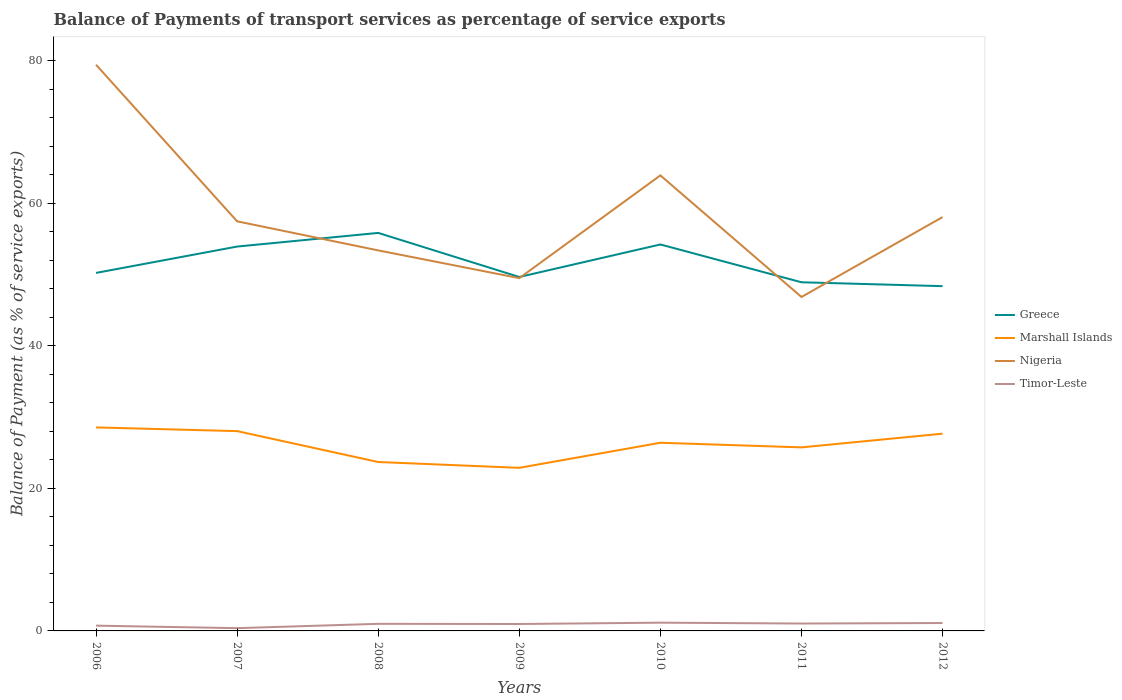Across all years, what is the maximum balance of payments of transport services in Marshall Islands?
Keep it short and to the point. 22.89. In which year was the balance of payments of transport services in Marshall Islands maximum?
Ensure brevity in your answer.  2009. What is the total balance of payments of transport services in Timor-Leste in the graph?
Keep it short and to the point. 0.35. What is the difference between the highest and the second highest balance of payments of transport services in Marshall Islands?
Your answer should be very brief. 5.67. How many lines are there?
Your response must be concise. 4. Does the graph contain grids?
Make the answer very short. No. How many legend labels are there?
Provide a short and direct response. 4. What is the title of the graph?
Give a very brief answer. Balance of Payments of transport services as percentage of service exports. Does "Slovak Republic" appear as one of the legend labels in the graph?
Your answer should be compact. No. What is the label or title of the X-axis?
Give a very brief answer. Years. What is the label or title of the Y-axis?
Your answer should be very brief. Balance of Payment (as % of service exports). What is the Balance of Payment (as % of service exports) in Greece in 2006?
Ensure brevity in your answer.  50.25. What is the Balance of Payment (as % of service exports) in Marshall Islands in 2006?
Your answer should be compact. 28.56. What is the Balance of Payment (as % of service exports) in Nigeria in 2006?
Your answer should be very brief. 79.47. What is the Balance of Payment (as % of service exports) in Timor-Leste in 2006?
Ensure brevity in your answer.  0.74. What is the Balance of Payment (as % of service exports) in Greece in 2007?
Keep it short and to the point. 53.95. What is the Balance of Payment (as % of service exports) in Marshall Islands in 2007?
Your answer should be compact. 28.05. What is the Balance of Payment (as % of service exports) in Nigeria in 2007?
Your answer should be compact. 57.49. What is the Balance of Payment (as % of service exports) in Timor-Leste in 2007?
Offer a very short reply. 0.39. What is the Balance of Payment (as % of service exports) in Greece in 2008?
Offer a very short reply. 55.87. What is the Balance of Payment (as % of service exports) of Marshall Islands in 2008?
Make the answer very short. 23.71. What is the Balance of Payment (as % of service exports) of Nigeria in 2008?
Keep it short and to the point. 53.41. What is the Balance of Payment (as % of service exports) in Timor-Leste in 2008?
Offer a very short reply. 1. What is the Balance of Payment (as % of service exports) of Greece in 2009?
Provide a short and direct response. 49.68. What is the Balance of Payment (as % of service exports) in Marshall Islands in 2009?
Ensure brevity in your answer.  22.89. What is the Balance of Payment (as % of service exports) of Nigeria in 2009?
Provide a succinct answer. 49.52. What is the Balance of Payment (as % of service exports) of Timor-Leste in 2009?
Your response must be concise. 0.97. What is the Balance of Payment (as % of service exports) of Greece in 2010?
Your answer should be very brief. 54.25. What is the Balance of Payment (as % of service exports) in Marshall Islands in 2010?
Keep it short and to the point. 26.41. What is the Balance of Payment (as % of service exports) of Nigeria in 2010?
Your response must be concise. 63.94. What is the Balance of Payment (as % of service exports) of Timor-Leste in 2010?
Your response must be concise. 1.16. What is the Balance of Payment (as % of service exports) in Greece in 2011?
Your response must be concise. 48.94. What is the Balance of Payment (as % of service exports) of Marshall Islands in 2011?
Provide a short and direct response. 25.76. What is the Balance of Payment (as % of service exports) in Nigeria in 2011?
Make the answer very short. 46.87. What is the Balance of Payment (as % of service exports) in Timor-Leste in 2011?
Make the answer very short. 1.04. What is the Balance of Payment (as % of service exports) of Greece in 2012?
Your answer should be compact. 48.39. What is the Balance of Payment (as % of service exports) of Marshall Islands in 2012?
Provide a short and direct response. 27.69. What is the Balance of Payment (as % of service exports) of Nigeria in 2012?
Provide a succinct answer. 58.09. What is the Balance of Payment (as % of service exports) in Timor-Leste in 2012?
Offer a very short reply. 1.11. Across all years, what is the maximum Balance of Payment (as % of service exports) in Greece?
Keep it short and to the point. 55.87. Across all years, what is the maximum Balance of Payment (as % of service exports) in Marshall Islands?
Give a very brief answer. 28.56. Across all years, what is the maximum Balance of Payment (as % of service exports) in Nigeria?
Make the answer very short. 79.47. Across all years, what is the maximum Balance of Payment (as % of service exports) of Timor-Leste?
Keep it short and to the point. 1.16. Across all years, what is the minimum Balance of Payment (as % of service exports) of Greece?
Your answer should be very brief. 48.39. Across all years, what is the minimum Balance of Payment (as % of service exports) in Marshall Islands?
Keep it short and to the point. 22.89. Across all years, what is the minimum Balance of Payment (as % of service exports) in Nigeria?
Your answer should be compact. 46.87. Across all years, what is the minimum Balance of Payment (as % of service exports) of Timor-Leste?
Keep it short and to the point. 0.39. What is the total Balance of Payment (as % of service exports) in Greece in the graph?
Your response must be concise. 361.34. What is the total Balance of Payment (as % of service exports) of Marshall Islands in the graph?
Offer a terse response. 183.08. What is the total Balance of Payment (as % of service exports) of Nigeria in the graph?
Provide a succinct answer. 408.81. What is the total Balance of Payment (as % of service exports) of Timor-Leste in the graph?
Your answer should be compact. 6.4. What is the difference between the Balance of Payment (as % of service exports) in Greece in 2006 and that in 2007?
Offer a terse response. -3.7. What is the difference between the Balance of Payment (as % of service exports) in Marshall Islands in 2006 and that in 2007?
Offer a very short reply. 0.52. What is the difference between the Balance of Payment (as % of service exports) of Nigeria in 2006 and that in 2007?
Provide a short and direct response. 21.98. What is the difference between the Balance of Payment (as % of service exports) in Timor-Leste in 2006 and that in 2007?
Your answer should be very brief. 0.35. What is the difference between the Balance of Payment (as % of service exports) in Greece in 2006 and that in 2008?
Provide a succinct answer. -5.61. What is the difference between the Balance of Payment (as % of service exports) in Marshall Islands in 2006 and that in 2008?
Keep it short and to the point. 4.85. What is the difference between the Balance of Payment (as % of service exports) in Nigeria in 2006 and that in 2008?
Your answer should be compact. 26.06. What is the difference between the Balance of Payment (as % of service exports) of Timor-Leste in 2006 and that in 2008?
Offer a very short reply. -0.26. What is the difference between the Balance of Payment (as % of service exports) of Greece in 2006 and that in 2009?
Offer a terse response. 0.57. What is the difference between the Balance of Payment (as % of service exports) in Marshall Islands in 2006 and that in 2009?
Provide a succinct answer. 5.67. What is the difference between the Balance of Payment (as % of service exports) of Nigeria in 2006 and that in 2009?
Your response must be concise. 29.95. What is the difference between the Balance of Payment (as % of service exports) in Timor-Leste in 2006 and that in 2009?
Make the answer very short. -0.23. What is the difference between the Balance of Payment (as % of service exports) in Greece in 2006 and that in 2010?
Your answer should be compact. -3.99. What is the difference between the Balance of Payment (as % of service exports) of Marshall Islands in 2006 and that in 2010?
Offer a very short reply. 2.15. What is the difference between the Balance of Payment (as % of service exports) of Nigeria in 2006 and that in 2010?
Give a very brief answer. 15.53. What is the difference between the Balance of Payment (as % of service exports) of Timor-Leste in 2006 and that in 2010?
Offer a very short reply. -0.42. What is the difference between the Balance of Payment (as % of service exports) in Greece in 2006 and that in 2011?
Offer a very short reply. 1.31. What is the difference between the Balance of Payment (as % of service exports) of Marshall Islands in 2006 and that in 2011?
Make the answer very short. 2.8. What is the difference between the Balance of Payment (as % of service exports) of Nigeria in 2006 and that in 2011?
Offer a terse response. 32.6. What is the difference between the Balance of Payment (as % of service exports) of Timor-Leste in 2006 and that in 2011?
Give a very brief answer. -0.3. What is the difference between the Balance of Payment (as % of service exports) in Greece in 2006 and that in 2012?
Ensure brevity in your answer.  1.86. What is the difference between the Balance of Payment (as % of service exports) in Marshall Islands in 2006 and that in 2012?
Provide a succinct answer. 0.88. What is the difference between the Balance of Payment (as % of service exports) of Nigeria in 2006 and that in 2012?
Your answer should be compact. 21.38. What is the difference between the Balance of Payment (as % of service exports) of Timor-Leste in 2006 and that in 2012?
Offer a terse response. -0.37. What is the difference between the Balance of Payment (as % of service exports) in Greece in 2007 and that in 2008?
Offer a terse response. -1.92. What is the difference between the Balance of Payment (as % of service exports) of Marshall Islands in 2007 and that in 2008?
Provide a short and direct response. 4.34. What is the difference between the Balance of Payment (as % of service exports) in Nigeria in 2007 and that in 2008?
Give a very brief answer. 4.08. What is the difference between the Balance of Payment (as % of service exports) of Timor-Leste in 2007 and that in 2008?
Make the answer very short. -0.61. What is the difference between the Balance of Payment (as % of service exports) in Greece in 2007 and that in 2009?
Give a very brief answer. 4.27. What is the difference between the Balance of Payment (as % of service exports) in Marshall Islands in 2007 and that in 2009?
Your answer should be very brief. 5.15. What is the difference between the Balance of Payment (as % of service exports) in Nigeria in 2007 and that in 2009?
Your answer should be very brief. 7.98. What is the difference between the Balance of Payment (as % of service exports) of Timor-Leste in 2007 and that in 2009?
Provide a succinct answer. -0.58. What is the difference between the Balance of Payment (as % of service exports) in Greece in 2007 and that in 2010?
Your answer should be very brief. -0.29. What is the difference between the Balance of Payment (as % of service exports) in Marshall Islands in 2007 and that in 2010?
Provide a short and direct response. 1.63. What is the difference between the Balance of Payment (as % of service exports) of Nigeria in 2007 and that in 2010?
Your answer should be compact. -6.45. What is the difference between the Balance of Payment (as % of service exports) in Timor-Leste in 2007 and that in 2010?
Your answer should be very brief. -0.77. What is the difference between the Balance of Payment (as % of service exports) in Greece in 2007 and that in 2011?
Provide a short and direct response. 5.01. What is the difference between the Balance of Payment (as % of service exports) in Marshall Islands in 2007 and that in 2011?
Provide a succinct answer. 2.28. What is the difference between the Balance of Payment (as % of service exports) in Nigeria in 2007 and that in 2011?
Your answer should be compact. 10.62. What is the difference between the Balance of Payment (as % of service exports) of Timor-Leste in 2007 and that in 2011?
Ensure brevity in your answer.  -0.65. What is the difference between the Balance of Payment (as % of service exports) in Greece in 2007 and that in 2012?
Your response must be concise. 5.56. What is the difference between the Balance of Payment (as % of service exports) in Marshall Islands in 2007 and that in 2012?
Keep it short and to the point. 0.36. What is the difference between the Balance of Payment (as % of service exports) in Nigeria in 2007 and that in 2012?
Your response must be concise. -0.6. What is the difference between the Balance of Payment (as % of service exports) of Timor-Leste in 2007 and that in 2012?
Your answer should be very brief. -0.72. What is the difference between the Balance of Payment (as % of service exports) of Greece in 2008 and that in 2009?
Offer a terse response. 6.19. What is the difference between the Balance of Payment (as % of service exports) in Marshall Islands in 2008 and that in 2009?
Your answer should be very brief. 0.82. What is the difference between the Balance of Payment (as % of service exports) in Nigeria in 2008 and that in 2009?
Your answer should be very brief. 3.89. What is the difference between the Balance of Payment (as % of service exports) in Timor-Leste in 2008 and that in 2009?
Keep it short and to the point. 0.02. What is the difference between the Balance of Payment (as % of service exports) of Greece in 2008 and that in 2010?
Offer a very short reply. 1.62. What is the difference between the Balance of Payment (as % of service exports) of Marshall Islands in 2008 and that in 2010?
Your response must be concise. -2.7. What is the difference between the Balance of Payment (as % of service exports) of Nigeria in 2008 and that in 2010?
Keep it short and to the point. -10.53. What is the difference between the Balance of Payment (as % of service exports) in Timor-Leste in 2008 and that in 2010?
Ensure brevity in your answer.  -0.16. What is the difference between the Balance of Payment (as % of service exports) of Greece in 2008 and that in 2011?
Make the answer very short. 6.93. What is the difference between the Balance of Payment (as % of service exports) of Marshall Islands in 2008 and that in 2011?
Make the answer very short. -2.05. What is the difference between the Balance of Payment (as % of service exports) of Nigeria in 2008 and that in 2011?
Provide a succinct answer. 6.54. What is the difference between the Balance of Payment (as % of service exports) of Timor-Leste in 2008 and that in 2011?
Make the answer very short. -0.04. What is the difference between the Balance of Payment (as % of service exports) in Greece in 2008 and that in 2012?
Keep it short and to the point. 7.47. What is the difference between the Balance of Payment (as % of service exports) of Marshall Islands in 2008 and that in 2012?
Make the answer very short. -3.98. What is the difference between the Balance of Payment (as % of service exports) in Nigeria in 2008 and that in 2012?
Your response must be concise. -4.68. What is the difference between the Balance of Payment (as % of service exports) of Timor-Leste in 2008 and that in 2012?
Provide a short and direct response. -0.11. What is the difference between the Balance of Payment (as % of service exports) of Greece in 2009 and that in 2010?
Your answer should be compact. -4.57. What is the difference between the Balance of Payment (as % of service exports) in Marshall Islands in 2009 and that in 2010?
Provide a succinct answer. -3.52. What is the difference between the Balance of Payment (as % of service exports) in Nigeria in 2009 and that in 2010?
Your answer should be compact. -14.43. What is the difference between the Balance of Payment (as % of service exports) in Timor-Leste in 2009 and that in 2010?
Your answer should be very brief. -0.19. What is the difference between the Balance of Payment (as % of service exports) in Greece in 2009 and that in 2011?
Provide a short and direct response. 0.74. What is the difference between the Balance of Payment (as % of service exports) in Marshall Islands in 2009 and that in 2011?
Your response must be concise. -2.87. What is the difference between the Balance of Payment (as % of service exports) in Nigeria in 2009 and that in 2011?
Ensure brevity in your answer.  2.64. What is the difference between the Balance of Payment (as % of service exports) of Timor-Leste in 2009 and that in 2011?
Provide a short and direct response. -0.07. What is the difference between the Balance of Payment (as % of service exports) of Marshall Islands in 2009 and that in 2012?
Provide a short and direct response. -4.8. What is the difference between the Balance of Payment (as % of service exports) of Nigeria in 2009 and that in 2012?
Provide a succinct answer. -8.57. What is the difference between the Balance of Payment (as % of service exports) of Timor-Leste in 2009 and that in 2012?
Make the answer very short. -0.14. What is the difference between the Balance of Payment (as % of service exports) in Greece in 2010 and that in 2011?
Keep it short and to the point. 5.31. What is the difference between the Balance of Payment (as % of service exports) in Marshall Islands in 2010 and that in 2011?
Ensure brevity in your answer.  0.65. What is the difference between the Balance of Payment (as % of service exports) of Nigeria in 2010 and that in 2011?
Your answer should be compact. 17.07. What is the difference between the Balance of Payment (as % of service exports) of Timor-Leste in 2010 and that in 2011?
Provide a short and direct response. 0.12. What is the difference between the Balance of Payment (as % of service exports) in Greece in 2010 and that in 2012?
Make the answer very short. 5.85. What is the difference between the Balance of Payment (as % of service exports) in Marshall Islands in 2010 and that in 2012?
Your answer should be very brief. -1.27. What is the difference between the Balance of Payment (as % of service exports) in Nigeria in 2010 and that in 2012?
Your response must be concise. 5.85. What is the difference between the Balance of Payment (as % of service exports) of Timor-Leste in 2010 and that in 2012?
Your answer should be very brief. 0.05. What is the difference between the Balance of Payment (as % of service exports) in Greece in 2011 and that in 2012?
Provide a short and direct response. 0.55. What is the difference between the Balance of Payment (as % of service exports) of Marshall Islands in 2011 and that in 2012?
Your answer should be compact. -1.92. What is the difference between the Balance of Payment (as % of service exports) of Nigeria in 2011 and that in 2012?
Keep it short and to the point. -11.22. What is the difference between the Balance of Payment (as % of service exports) in Timor-Leste in 2011 and that in 2012?
Provide a succinct answer. -0.07. What is the difference between the Balance of Payment (as % of service exports) in Greece in 2006 and the Balance of Payment (as % of service exports) in Marshall Islands in 2007?
Your answer should be very brief. 22.21. What is the difference between the Balance of Payment (as % of service exports) of Greece in 2006 and the Balance of Payment (as % of service exports) of Nigeria in 2007?
Offer a very short reply. -7.24. What is the difference between the Balance of Payment (as % of service exports) of Greece in 2006 and the Balance of Payment (as % of service exports) of Timor-Leste in 2007?
Offer a terse response. 49.86. What is the difference between the Balance of Payment (as % of service exports) in Marshall Islands in 2006 and the Balance of Payment (as % of service exports) in Nigeria in 2007?
Provide a succinct answer. -28.93. What is the difference between the Balance of Payment (as % of service exports) in Marshall Islands in 2006 and the Balance of Payment (as % of service exports) in Timor-Leste in 2007?
Offer a very short reply. 28.18. What is the difference between the Balance of Payment (as % of service exports) of Nigeria in 2006 and the Balance of Payment (as % of service exports) of Timor-Leste in 2007?
Your answer should be very brief. 79.08. What is the difference between the Balance of Payment (as % of service exports) in Greece in 2006 and the Balance of Payment (as % of service exports) in Marshall Islands in 2008?
Your answer should be compact. 26.54. What is the difference between the Balance of Payment (as % of service exports) of Greece in 2006 and the Balance of Payment (as % of service exports) of Nigeria in 2008?
Your answer should be very brief. -3.16. What is the difference between the Balance of Payment (as % of service exports) of Greece in 2006 and the Balance of Payment (as % of service exports) of Timor-Leste in 2008?
Provide a succinct answer. 49.26. What is the difference between the Balance of Payment (as % of service exports) of Marshall Islands in 2006 and the Balance of Payment (as % of service exports) of Nigeria in 2008?
Your answer should be compact. -24.85. What is the difference between the Balance of Payment (as % of service exports) of Marshall Islands in 2006 and the Balance of Payment (as % of service exports) of Timor-Leste in 2008?
Your answer should be very brief. 27.57. What is the difference between the Balance of Payment (as % of service exports) in Nigeria in 2006 and the Balance of Payment (as % of service exports) in Timor-Leste in 2008?
Give a very brief answer. 78.48. What is the difference between the Balance of Payment (as % of service exports) in Greece in 2006 and the Balance of Payment (as % of service exports) in Marshall Islands in 2009?
Offer a terse response. 27.36. What is the difference between the Balance of Payment (as % of service exports) in Greece in 2006 and the Balance of Payment (as % of service exports) in Nigeria in 2009?
Offer a terse response. 0.74. What is the difference between the Balance of Payment (as % of service exports) in Greece in 2006 and the Balance of Payment (as % of service exports) in Timor-Leste in 2009?
Your answer should be compact. 49.28. What is the difference between the Balance of Payment (as % of service exports) in Marshall Islands in 2006 and the Balance of Payment (as % of service exports) in Nigeria in 2009?
Your answer should be compact. -20.95. What is the difference between the Balance of Payment (as % of service exports) of Marshall Islands in 2006 and the Balance of Payment (as % of service exports) of Timor-Leste in 2009?
Keep it short and to the point. 27.59. What is the difference between the Balance of Payment (as % of service exports) in Nigeria in 2006 and the Balance of Payment (as % of service exports) in Timor-Leste in 2009?
Make the answer very short. 78.5. What is the difference between the Balance of Payment (as % of service exports) in Greece in 2006 and the Balance of Payment (as % of service exports) in Marshall Islands in 2010?
Your response must be concise. 23.84. What is the difference between the Balance of Payment (as % of service exports) in Greece in 2006 and the Balance of Payment (as % of service exports) in Nigeria in 2010?
Your answer should be compact. -13.69. What is the difference between the Balance of Payment (as % of service exports) of Greece in 2006 and the Balance of Payment (as % of service exports) of Timor-Leste in 2010?
Keep it short and to the point. 49.1. What is the difference between the Balance of Payment (as % of service exports) in Marshall Islands in 2006 and the Balance of Payment (as % of service exports) in Nigeria in 2010?
Your answer should be very brief. -35.38. What is the difference between the Balance of Payment (as % of service exports) of Marshall Islands in 2006 and the Balance of Payment (as % of service exports) of Timor-Leste in 2010?
Your answer should be very brief. 27.41. What is the difference between the Balance of Payment (as % of service exports) in Nigeria in 2006 and the Balance of Payment (as % of service exports) in Timor-Leste in 2010?
Provide a succinct answer. 78.32. What is the difference between the Balance of Payment (as % of service exports) in Greece in 2006 and the Balance of Payment (as % of service exports) in Marshall Islands in 2011?
Make the answer very short. 24.49. What is the difference between the Balance of Payment (as % of service exports) of Greece in 2006 and the Balance of Payment (as % of service exports) of Nigeria in 2011?
Provide a short and direct response. 3.38. What is the difference between the Balance of Payment (as % of service exports) of Greece in 2006 and the Balance of Payment (as % of service exports) of Timor-Leste in 2011?
Give a very brief answer. 49.22. What is the difference between the Balance of Payment (as % of service exports) of Marshall Islands in 2006 and the Balance of Payment (as % of service exports) of Nigeria in 2011?
Ensure brevity in your answer.  -18.31. What is the difference between the Balance of Payment (as % of service exports) of Marshall Islands in 2006 and the Balance of Payment (as % of service exports) of Timor-Leste in 2011?
Provide a succinct answer. 27.53. What is the difference between the Balance of Payment (as % of service exports) of Nigeria in 2006 and the Balance of Payment (as % of service exports) of Timor-Leste in 2011?
Offer a terse response. 78.44. What is the difference between the Balance of Payment (as % of service exports) in Greece in 2006 and the Balance of Payment (as % of service exports) in Marshall Islands in 2012?
Keep it short and to the point. 22.56. What is the difference between the Balance of Payment (as % of service exports) of Greece in 2006 and the Balance of Payment (as % of service exports) of Nigeria in 2012?
Your answer should be compact. -7.84. What is the difference between the Balance of Payment (as % of service exports) of Greece in 2006 and the Balance of Payment (as % of service exports) of Timor-Leste in 2012?
Keep it short and to the point. 49.14. What is the difference between the Balance of Payment (as % of service exports) in Marshall Islands in 2006 and the Balance of Payment (as % of service exports) in Nigeria in 2012?
Your answer should be compact. -29.53. What is the difference between the Balance of Payment (as % of service exports) in Marshall Islands in 2006 and the Balance of Payment (as % of service exports) in Timor-Leste in 2012?
Offer a terse response. 27.46. What is the difference between the Balance of Payment (as % of service exports) in Nigeria in 2006 and the Balance of Payment (as % of service exports) in Timor-Leste in 2012?
Give a very brief answer. 78.36. What is the difference between the Balance of Payment (as % of service exports) of Greece in 2007 and the Balance of Payment (as % of service exports) of Marshall Islands in 2008?
Give a very brief answer. 30.24. What is the difference between the Balance of Payment (as % of service exports) in Greece in 2007 and the Balance of Payment (as % of service exports) in Nigeria in 2008?
Offer a very short reply. 0.54. What is the difference between the Balance of Payment (as % of service exports) in Greece in 2007 and the Balance of Payment (as % of service exports) in Timor-Leste in 2008?
Keep it short and to the point. 52.96. What is the difference between the Balance of Payment (as % of service exports) of Marshall Islands in 2007 and the Balance of Payment (as % of service exports) of Nigeria in 2008?
Provide a succinct answer. -25.37. What is the difference between the Balance of Payment (as % of service exports) of Marshall Islands in 2007 and the Balance of Payment (as % of service exports) of Timor-Leste in 2008?
Ensure brevity in your answer.  27.05. What is the difference between the Balance of Payment (as % of service exports) in Nigeria in 2007 and the Balance of Payment (as % of service exports) in Timor-Leste in 2008?
Your answer should be very brief. 56.5. What is the difference between the Balance of Payment (as % of service exports) of Greece in 2007 and the Balance of Payment (as % of service exports) of Marshall Islands in 2009?
Keep it short and to the point. 31.06. What is the difference between the Balance of Payment (as % of service exports) in Greece in 2007 and the Balance of Payment (as % of service exports) in Nigeria in 2009?
Ensure brevity in your answer.  4.43. What is the difference between the Balance of Payment (as % of service exports) of Greece in 2007 and the Balance of Payment (as % of service exports) of Timor-Leste in 2009?
Your answer should be compact. 52.98. What is the difference between the Balance of Payment (as % of service exports) in Marshall Islands in 2007 and the Balance of Payment (as % of service exports) in Nigeria in 2009?
Give a very brief answer. -21.47. What is the difference between the Balance of Payment (as % of service exports) in Marshall Islands in 2007 and the Balance of Payment (as % of service exports) in Timor-Leste in 2009?
Your answer should be very brief. 27.07. What is the difference between the Balance of Payment (as % of service exports) in Nigeria in 2007 and the Balance of Payment (as % of service exports) in Timor-Leste in 2009?
Offer a terse response. 56.52. What is the difference between the Balance of Payment (as % of service exports) in Greece in 2007 and the Balance of Payment (as % of service exports) in Marshall Islands in 2010?
Offer a very short reply. 27.54. What is the difference between the Balance of Payment (as % of service exports) in Greece in 2007 and the Balance of Payment (as % of service exports) in Nigeria in 2010?
Your answer should be very brief. -9.99. What is the difference between the Balance of Payment (as % of service exports) of Greece in 2007 and the Balance of Payment (as % of service exports) of Timor-Leste in 2010?
Make the answer very short. 52.79. What is the difference between the Balance of Payment (as % of service exports) in Marshall Islands in 2007 and the Balance of Payment (as % of service exports) in Nigeria in 2010?
Your answer should be compact. -35.9. What is the difference between the Balance of Payment (as % of service exports) of Marshall Islands in 2007 and the Balance of Payment (as % of service exports) of Timor-Leste in 2010?
Keep it short and to the point. 26.89. What is the difference between the Balance of Payment (as % of service exports) of Nigeria in 2007 and the Balance of Payment (as % of service exports) of Timor-Leste in 2010?
Your answer should be compact. 56.34. What is the difference between the Balance of Payment (as % of service exports) of Greece in 2007 and the Balance of Payment (as % of service exports) of Marshall Islands in 2011?
Your response must be concise. 28.19. What is the difference between the Balance of Payment (as % of service exports) of Greece in 2007 and the Balance of Payment (as % of service exports) of Nigeria in 2011?
Provide a short and direct response. 7.08. What is the difference between the Balance of Payment (as % of service exports) of Greece in 2007 and the Balance of Payment (as % of service exports) of Timor-Leste in 2011?
Ensure brevity in your answer.  52.91. What is the difference between the Balance of Payment (as % of service exports) in Marshall Islands in 2007 and the Balance of Payment (as % of service exports) in Nigeria in 2011?
Provide a succinct answer. -18.83. What is the difference between the Balance of Payment (as % of service exports) of Marshall Islands in 2007 and the Balance of Payment (as % of service exports) of Timor-Leste in 2011?
Your response must be concise. 27.01. What is the difference between the Balance of Payment (as % of service exports) of Nigeria in 2007 and the Balance of Payment (as % of service exports) of Timor-Leste in 2011?
Offer a terse response. 56.46. What is the difference between the Balance of Payment (as % of service exports) of Greece in 2007 and the Balance of Payment (as % of service exports) of Marshall Islands in 2012?
Your answer should be very brief. 26.26. What is the difference between the Balance of Payment (as % of service exports) of Greece in 2007 and the Balance of Payment (as % of service exports) of Nigeria in 2012?
Offer a terse response. -4.14. What is the difference between the Balance of Payment (as % of service exports) of Greece in 2007 and the Balance of Payment (as % of service exports) of Timor-Leste in 2012?
Keep it short and to the point. 52.84. What is the difference between the Balance of Payment (as % of service exports) of Marshall Islands in 2007 and the Balance of Payment (as % of service exports) of Nigeria in 2012?
Provide a succinct answer. -30.04. What is the difference between the Balance of Payment (as % of service exports) of Marshall Islands in 2007 and the Balance of Payment (as % of service exports) of Timor-Leste in 2012?
Provide a short and direct response. 26.94. What is the difference between the Balance of Payment (as % of service exports) of Nigeria in 2007 and the Balance of Payment (as % of service exports) of Timor-Leste in 2012?
Give a very brief answer. 56.38. What is the difference between the Balance of Payment (as % of service exports) of Greece in 2008 and the Balance of Payment (as % of service exports) of Marshall Islands in 2009?
Your answer should be compact. 32.98. What is the difference between the Balance of Payment (as % of service exports) of Greece in 2008 and the Balance of Payment (as % of service exports) of Nigeria in 2009?
Offer a very short reply. 6.35. What is the difference between the Balance of Payment (as % of service exports) in Greece in 2008 and the Balance of Payment (as % of service exports) in Timor-Leste in 2009?
Your answer should be compact. 54.9. What is the difference between the Balance of Payment (as % of service exports) in Marshall Islands in 2008 and the Balance of Payment (as % of service exports) in Nigeria in 2009?
Your answer should be compact. -25.81. What is the difference between the Balance of Payment (as % of service exports) of Marshall Islands in 2008 and the Balance of Payment (as % of service exports) of Timor-Leste in 2009?
Offer a very short reply. 22.74. What is the difference between the Balance of Payment (as % of service exports) of Nigeria in 2008 and the Balance of Payment (as % of service exports) of Timor-Leste in 2009?
Give a very brief answer. 52.44. What is the difference between the Balance of Payment (as % of service exports) in Greece in 2008 and the Balance of Payment (as % of service exports) in Marshall Islands in 2010?
Make the answer very short. 29.45. What is the difference between the Balance of Payment (as % of service exports) of Greece in 2008 and the Balance of Payment (as % of service exports) of Nigeria in 2010?
Ensure brevity in your answer.  -8.08. What is the difference between the Balance of Payment (as % of service exports) in Greece in 2008 and the Balance of Payment (as % of service exports) in Timor-Leste in 2010?
Offer a terse response. 54.71. What is the difference between the Balance of Payment (as % of service exports) of Marshall Islands in 2008 and the Balance of Payment (as % of service exports) of Nigeria in 2010?
Your response must be concise. -40.23. What is the difference between the Balance of Payment (as % of service exports) in Marshall Islands in 2008 and the Balance of Payment (as % of service exports) in Timor-Leste in 2010?
Ensure brevity in your answer.  22.55. What is the difference between the Balance of Payment (as % of service exports) in Nigeria in 2008 and the Balance of Payment (as % of service exports) in Timor-Leste in 2010?
Keep it short and to the point. 52.25. What is the difference between the Balance of Payment (as % of service exports) of Greece in 2008 and the Balance of Payment (as % of service exports) of Marshall Islands in 2011?
Your answer should be very brief. 30.1. What is the difference between the Balance of Payment (as % of service exports) of Greece in 2008 and the Balance of Payment (as % of service exports) of Nigeria in 2011?
Keep it short and to the point. 8.99. What is the difference between the Balance of Payment (as % of service exports) of Greece in 2008 and the Balance of Payment (as % of service exports) of Timor-Leste in 2011?
Offer a very short reply. 54.83. What is the difference between the Balance of Payment (as % of service exports) of Marshall Islands in 2008 and the Balance of Payment (as % of service exports) of Nigeria in 2011?
Give a very brief answer. -23.16. What is the difference between the Balance of Payment (as % of service exports) in Marshall Islands in 2008 and the Balance of Payment (as % of service exports) in Timor-Leste in 2011?
Your response must be concise. 22.67. What is the difference between the Balance of Payment (as % of service exports) of Nigeria in 2008 and the Balance of Payment (as % of service exports) of Timor-Leste in 2011?
Your answer should be very brief. 52.38. What is the difference between the Balance of Payment (as % of service exports) in Greece in 2008 and the Balance of Payment (as % of service exports) in Marshall Islands in 2012?
Ensure brevity in your answer.  28.18. What is the difference between the Balance of Payment (as % of service exports) in Greece in 2008 and the Balance of Payment (as % of service exports) in Nigeria in 2012?
Keep it short and to the point. -2.22. What is the difference between the Balance of Payment (as % of service exports) in Greece in 2008 and the Balance of Payment (as % of service exports) in Timor-Leste in 2012?
Your response must be concise. 54.76. What is the difference between the Balance of Payment (as % of service exports) in Marshall Islands in 2008 and the Balance of Payment (as % of service exports) in Nigeria in 2012?
Your answer should be compact. -34.38. What is the difference between the Balance of Payment (as % of service exports) of Marshall Islands in 2008 and the Balance of Payment (as % of service exports) of Timor-Leste in 2012?
Offer a terse response. 22.6. What is the difference between the Balance of Payment (as % of service exports) in Nigeria in 2008 and the Balance of Payment (as % of service exports) in Timor-Leste in 2012?
Your response must be concise. 52.3. What is the difference between the Balance of Payment (as % of service exports) in Greece in 2009 and the Balance of Payment (as % of service exports) in Marshall Islands in 2010?
Provide a succinct answer. 23.27. What is the difference between the Balance of Payment (as % of service exports) of Greece in 2009 and the Balance of Payment (as % of service exports) of Nigeria in 2010?
Offer a very short reply. -14.26. What is the difference between the Balance of Payment (as % of service exports) of Greece in 2009 and the Balance of Payment (as % of service exports) of Timor-Leste in 2010?
Ensure brevity in your answer.  48.52. What is the difference between the Balance of Payment (as % of service exports) in Marshall Islands in 2009 and the Balance of Payment (as % of service exports) in Nigeria in 2010?
Your response must be concise. -41.05. What is the difference between the Balance of Payment (as % of service exports) in Marshall Islands in 2009 and the Balance of Payment (as % of service exports) in Timor-Leste in 2010?
Your answer should be compact. 21.73. What is the difference between the Balance of Payment (as % of service exports) of Nigeria in 2009 and the Balance of Payment (as % of service exports) of Timor-Leste in 2010?
Ensure brevity in your answer.  48.36. What is the difference between the Balance of Payment (as % of service exports) of Greece in 2009 and the Balance of Payment (as % of service exports) of Marshall Islands in 2011?
Keep it short and to the point. 23.92. What is the difference between the Balance of Payment (as % of service exports) of Greece in 2009 and the Balance of Payment (as % of service exports) of Nigeria in 2011?
Offer a terse response. 2.81. What is the difference between the Balance of Payment (as % of service exports) in Greece in 2009 and the Balance of Payment (as % of service exports) in Timor-Leste in 2011?
Your answer should be compact. 48.64. What is the difference between the Balance of Payment (as % of service exports) in Marshall Islands in 2009 and the Balance of Payment (as % of service exports) in Nigeria in 2011?
Provide a succinct answer. -23.98. What is the difference between the Balance of Payment (as % of service exports) in Marshall Islands in 2009 and the Balance of Payment (as % of service exports) in Timor-Leste in 2011?
Your answer should be compact. 21.85. What is the difference between the Balance of Payment (as % of service exports) of Nigeria in 2009 and the Balance of Payment (as % of service exports) of Timor-Leste in 2011?
Offer a terse response. 48.48. What is the difference between the Balance of Payment (as % of service exports) in Greece in 2009 and the Balance of Payment (as % of service exports) in Marshall Islands in 2012?
Ensure brevity in your answer.  21.99. What is the difference between the Balance of Payment (as % of service exports) in Greece in 2009 and the Balance of Payment (as % of service exports) in Nigeria in 2012?
Keep it short and to the point. -8.41. What is the difference between the Balance of Payment (as % of service exports) in Greece in 2009 and the Balance of Payment (as % of service exports) in Timor-Leste in 2012?
Make the answer very short. 48.57. What is the difference between the Balance of Payment (as % of service exports) in Marshall Islands in 2009 and the Balance of Payment (as % of service exports) in Nigeria in 2012?
Offer a terse response. -35.2. What is the difference between the Balance of Payment (as % of service exports) of Marshall Islands in 2009 and the Balance of Payment (as % of service exports) of Timor-Leste in 2012?
Your response must be concise. 21.78. What is the difference between the Balance of Payment (as % of service exports) in Nigeria in 2009 and the Balance of Payment (as % of service exports) in Timor-Leste in 2012?
Give a very brief answer. 48.41. What is the difference between the Balance of Payment (as % of service exports) in Greece in 2010 and the Balance of Payment (as % of service exports) in Marshall Islands in 2011?
Offer a very short reply. 28.48. What is the difference between the Balance of Payment (as % of service exports) in Greece in 2010 and the Balance of Payment (as % of service exports) in Nigeria in 2011?
Your answer should be very brief. 7.37. What is the difference between the Balance of Payment (as % of service exports) of Greece in 2010 and the Balance of Payment (as % of service exports) of Timor-Leste in 2011?
Offer a terse response. 53.21. What is the difference between the Balance of Payment (as % of service exports) in Marshall Islands in 2010 and the Balance of Payment (as % of service exports) in Nigeria in 2011?
Keep it short and to the point. -20.46. What is the difference between the Balance of Payment (as % of service exports) in Marshall Islands in 2010 and the Balance of Payment (as % of service exports) in Timor-Leste in 2011?
Provide a short and direct response. 25.38. What is the difference between the Balance of Payment (as % of service exports) in Nigeria in 2010 and the Balance of Payment (as % of service exports) in Timor-Leste in 2011?
Provide a succinct answer. 62.91. What is the difference between the Balance of Payment (as % of service exports) of Greece in 2010 and the Balance of Payment (as % of service exports) of Marshall Islands in 2012?
Provide a short and direct response. 26.56. What is the difference between the Balance of Payment (as % of service exports) in Greece in 2010 and the Balance of Payment (as % of service exports) in Nigeria in 2012?
Keep it short and to the point. -3.84. What is the difference between the Balance of Payment (as % of service exports) in Greece in 2010 and the Balance of Payment (as % of service exports) in Timor-Leste in 2012?
Your answer should be very brief. 53.14. What is the difference between the Balance of Payment (as % of service exports) in Marshall Islands in 2010 and the Balance of Payment (as % of service exports) in Nigeria in 2012?
Your response must be concise. -31.68. What is the difference between the Balance of Payment (as % of service exports) in Marshall Islands in 2010 and the Balance of Payment (as % of service exports) in Timor-Leste in 2012?
Provide a succinct answer. 25.31. What is the difference between the Balance of Payment (as % of service exports) of Nigeria in 2010 and the Balance of Payment (as % of service exports) of Timor-Leste in 2012?
Provide a succinct answer. 62.83. What is the difference between the Balance of Payment (as % of service exports) of Greece in 2011 and the Balance of Payment (as % of service exports) of Marshall Islands in 2012?
Your response must be concise. 21.25. What is the difference between the Balance of Payment (as % of service exports) in Greece in 2011 and the Balance of Payment (as % of service exports) in Nigeria in 2012?
Your response must be concise. -9.15. What is the difference between the Balance of Payment (as % of service exports) in Greece in 2011 and the Balance of Payment (as % of service exports) in Timor-Leste in 2012?
Provide a short and direct response. 47.83. What is the difference between the Balance of Payment (as % of service exports) in Marshall Islands in 2011 and the Balance of Payment (as % of service exports) in Nigeria in 2012?
Ensure brevity in your answer.  -32.33. What is the difference between the Balance of Payment (as % of service exports) in Marshall Islands in 2011 and the Balance of Payment (as % of service exports) in Timor-Leste in 2012?
Ensure brevity in your answer.  24.66. What is the difference between the Balance of Payment (as % of service exports) in Nigeria in 2011 and the Balance of Payment (as % of service exports) in Timor-Leste in 2012?
Your response must be concise. 45.77. What is the average Balance of Payment (as % of service exports) of Greece per year?
Keep it short and to the point. 51.62. What is the average Balance of Payment (as % of service exports) in Marshall Islands per year?
Keep it short and to the point. 26.15. What is the average Balance of Payment (as % of service exports) in Nigeria per year?
Provide a succinct answer. 58.4. What is the average Balance of Payment (as % of service exports) of Timor-Leste per year?
Provide a short and direct response. 0.91. In the year 2006, what is the difference between the Balance of Payment (as % of service exports) of Greece and Balance of Payment (as % of service exports) of Marshall Islands?
Your response must be concise. 21.69. In the year 2006, what is the difference between the Balance of Payment (as % of service exports) in Greece and Balance of Payment (as % of service exports) in Nigeria?
Give a very brief answer. -29.22. In the year 2006, what is the difference between the Balance of Payment (as % of service exports) of Greece and Balance of Payment (as % of service exports) of Timor-Leste?
Give a very brief answer. 49.51. In the year 2006, what is the difference between the Balance of Payment (as % of service exports) of Marshall Islands and Balance of Payment (as % of service exports) of Nigeria?
Your response must be concise. -50.91. In the year 2006, what is the difference between the Balance of Payment (as % of service exports) of Marshall Islands and Balance of Payment (as % of service exports) of Timor-Leste?
Make the answer very short. 27.83. In the year 2006, what is the difference between the Balance of Payment (as % of service exports) in Nigeria and Balance of Payment (as % of service exports) in Timor-Leste?
Your response must be concise. 78.73. In the year 2007, what is the difference between the Balance of Payment (as % of service exports) of Greece and Balance of Payment (as % of service exports) of Marshall Islands?
Your answer should be very brief. 25.91. In the year 2007, what is the difference between the Balance of Payment (as % of service exports) of Greece and Balance of Payment (as % of service exports) of Nigeria?
Your response must be concise. -3.54. In the year 2007, what is the difference between the Balance of Payment (as % of service exports) in Greece and Balance of Payment (as % of service exports) in Timor-Leste?
Offer a very short reply. 53.56. In the year 2007, what is the difference between the Balance of Payment (as % of service exports) of Marshall Islands and Balance of Payment (as % of service exports) of Nigeria?
Keep it short and to the point. -29.45. In the year 2007, what is the difference between the Balance of Payment (as % of service exports) in Marshall Islands and Balance of Payment (as % of service exports) in Timor-Leste?
Give a very brief answer. 27.66. In the year 2007, what is the difference between the Balance of Payment (as % of service exports) in Nigeria and Balance of Payment (as % of service exports) in Timor-Leste?
Ensure brevity in your answer.  57.1. In the year 2008, what is the difference between the Balance of Payment (as % of service exports) of Greece and Balance of Payment (as % of service exports) of Marshall Islands?
Your answer should be compact. 32.16. In the year 2008, what is the difference between the Balance of Payment (as % of service exports) of Greece and Balance of Payment (as % of service exports) of Nigeria?
Your answer should be compact. 2.46. In the year 2008, what is the difference between the Balance of Payment (as % of service exports) of Greece and Balance of Payment (as % of service exports) of Timor-Leste?
Make the answer very short. 54.87. In the year 2008, what is the difference between the Balance of Payment (as % of service exports) of Marshall Islands and Balance of Payment (as % of service exports) of Nigeria?
Keep it short and to the point. -29.7. In the year 2008, what is the difference between the Balance of Payment (as % of service exports) in Marshall Islands and Balance of Payment (as % of service exports) in Timor-Leste?
Ensure brevity in your answer.  22.72. In the year 2008, what is the difference between the Balance of Payment (as % of service exports) of Nigeria and Balance of Payment (as % of service exports) of Timor-Leste?
Provide a succinct answer. 52.42. In the year 2009, what is the difference between the Balance of Payment (as % of service exports) of Greece and Balance of Payment (as % of service exports) of Marshall Islands?
Offer a terse response. 26.79. In the year 2009, what is the difference between the Balance of Payment (as % of service exports) in Greece and Balance of Payment (as % of service exports) in Nigeria?
Provide a succinct answer. 0.16. In the year 2009, what is the difference between the Balance of Payment (as % of service exports) of Greece and Balance of Payment (as % of service exports) of Timor-Leste?
Your response must be concise. 48.71. In the year 2009, what is the difference between the Balance of Payment (as % of service exports) in Marshall Islands and Balance of Payment (as % of service exports) in Nigeria?
Your answer should be compact. -26.63. In the year 2009, what is the difference between the Balance of Payment (as % of service exports) in Marshall Islands and Balance of Payment (as % of service exports) in Timor-Leste?
Your answer should be compact. 21.92. In the year 2009, what is the difference between the Balance of Payment (as % of service exports) in Nigeria and Balance of Payment (as % of service exports) in Timor-Leste?
Offer a very short reply. 48.55. In the year 2010, what is the difference between the Balance of Payment (as % of service exports) in Greece and Balance of Payment (as % of service exports) in Marshall Islands?
Ensure brevity in your answer.  27.83. In the year 2010, what is the difference between the Balance of Payment (as % of service exports) in Greece and Balance of Payment (as % of service exports) in Nigeria?
Provide a succinct answer. -9.7. In the year 2010, what is the difference between the Balance of Payment (as % of service exports) in Greece and Balance of Payment (as % of service exports) in Timor-Leste?
Provide a short and direct response. 53.09. In the year 2010, what is the difference between the Balance of Payment (as % of service exports) of Marshall Islands and Balance of Payment (as % of service exports) of Nigeria?
Provide a succinct answer. -37.53. In the year 2010, what is the difference between the Balance of Payment (as % of service exports) of Marshall Islands and Balance of Payment (as % of service exports) of Timor-Leste?
Provide a succinct answer. 25.26. In the year 2010, what is the difference between the Balance of Payment (as % of service exports) in Nigeria and Balance of Payment (as % of service exports) in Timor-Leste?
Your answer should be compact. 62.79. In the year 2011, what is the difference between the Balance of Payment (as % of service exports) in Greece and Balance of Payment (as % of service exports) in Marshall Islands?
Your answer should be compact. 23.18. In the year 2011, what is the difference between the Balance of Payment (as % of service exports) of Greece and Balance of Payment (as % of service exports) of Nigeria?
Offer a terse response. 2.07. In the year 2011, what is the difference between the Balance of Payment (as % of service exports) of Greece and Balance of Payment (as % of service exports) of Timor-Leste?
Ensure brevity in your answer.  47.9. In the year 2011, what is the difference between the Balance of Payment (as % of service exports) in Marshall Islands and Balance of Payment (as % of service exports) in Nigeria?
Your answer should be very brief. -21.11. In the year 2011, what is the difference between the Balance of Payment (as % of service exports) of Marshall Islands and Balance of Payment (as % of service exports) of Timor-Leste?
Ensure brevity in your answer.  24.73. In the year 2011, what is the difference between the Balance of Payment (as % of service exports) of Nigeria and Balance of Payment (as % of service exports) of Timor-Leste?
Provide a short and direct response. 45.84. In the year 2012, what is the difference between the Balance of Payment (as % of service exports) of Greece and Balance of Payment (as % of service exports) of Marshall Islands?
Your response must be concise. 20.71. In the year 2012, what is the difference between the Balance of Payment (as % of service exports) of Greece and Balance of Payment (as % of service exports) of Nigeria?
Make the answer very short. -9.7. In the year 2012, what is the difference between the Balance of Payment (as % of service exports) in Greece and Balance of Payment (as % of service exports) in Timor-Leste?
Offer a very short reply. 47.29. In the year 2012, what is the difference between the Balance of Payment (as % of service exports) in Marshall Islands and Balance of Payment (as % of service exports) in Nigeria?
Give a very brief answer. -30.4. In the year 2012, what is the difference between the Balance of Payment (as % of service exports) of Marshall Islands and Balance of Payment (as % of service exports) of Timor-Leste?
Give a very brief answer. 26.58. In the year 2012, what is the difference between the Balance of Payment (as % of service exports) in Nigeria and Balance of Payment (as % of service exports) in Timor-Leste?
Provide a short and direct response. 56.98. What is the ratio of the Balance of Payment (as % of service exports) in Greece in 2006 to that in 2007?
Your answer should be very brief. 0.93. What is the ratio of the Balance of Payment (as % of service exports) in Marshall Islands in 2006 to that in 2007?
Your answer should be very brief. 1.02. What is the ratio of the Balance of Payment (as % of service exports) of Nigeria in 2006 to that in 2007?
Your answer should be very brief. 1.38. What is the ratio of the Balance of Payment (as % of service exports) of Timor-Leste in 2006 to that in 2007?
Give a very brief answer. 1.9. What is the ratio of the Balance of Payment (as % of service exports) of Greece in 2006 to that in 2008?
Give a very brief answer. 0.9. What is the ratio of the Balance of Payment (as % of service exports) of Marshall Islands in 2006 to that in 2008?
Offer a terse response. 1.2. What is the ratio of the Balance of Payment (as % of service exports) in Nigeria in 2006 to that in 2008?
Your answer should be very brief. 1.49. What is the ratio of the Balance of Payment (as % of service exports) in Timor-Leste in 2006 to that in 2008?
Your response must be concise. 0.74. What is the ratio of the Balance of Payment (as % of service exports) of Greece in 2006 to that in 2009?
Provide a succinct answer. 1.01. What is the ratio of the Balance of Payment (as % of service exports) of Marshall Islands in 2006 to that in 2009?
Provide a short and direct response. 1.25. What is the ratio of the Balance of Payment (as % of service exports) of Nigeria in 2006 to that in 2009?
Make the answer very short. 1.6. What is the ratio of the Balance of Payment (as % of service exports) of Timor-Leste in 2006 to that in 2009?
Ensure brevity in your answer.  0.76. What is the ratio of the Balance of Payment (as % of service exports) of Greece in 2006 to that in 2010?
Your response must be concise. 0.93. What is the ratio of the Balance of Payment (as % of service exports) in Marshall Islands in 2006 to that in 2010?
Ensure brevity in your answer.  1.08. What is the ratio of the Balance of Payment (as % of service exports) of Nigeria in 2006 to that in 2010?
Keep it short and to the point. 1.24. What is the ratio of the Balance of Payment (as % of service exports) in Timor-Leste in 2006 to that in 2010?
Your response must be concise. 0.64. What is the ratio of the Balance of Payment (as % of service exports) in Greece in 2006 to that in 2011?
Your response must be concise. 1.03. What is the ratio of the Balance of Payment (as % of service exports) of Marshall Islands in 2006 to that in 2011?
Keep it short and to the point. 1.11. What is the ratio of the Balance of Payment (as % of service exports) of Nigeria in 2006 to that in 2011?
Keep it short and to the point. 1.7. What is the ratio of the Balance of Payment (as % of service exports) in Timor-Leste in 2006 to that in 2011?
Your answer should be very brief. 0.71. What is the ratio of the Balance of Payment (as % of service exports) of Greece in 2006 to that in 2012?
Give a very brief answer. 1.04. What is the ratio of the Balance of Payment (as % of service exports) of Marshall Islands in 2006 to that in 2012?
Offer a very short reply. 1.03. What is the ratio of the Balance of Payment (as % of service exports) in Nigeria in 2006 to that in 2012?
Offer a very short reply. 1.37. What is the ratio of the Balance of Payment (as % of service exports) of Timor-Leste in 2006 to that in 2012?
Make the answer very short. 0.67. What is the ratio of the Balance of Payment (as % of service exports) in Greece in 2007 to that in 2008?
Offer a terse response. 0.97. What is the ratio of the Balance of Payment (as % of service exports) in Marshall Islands in 2007 to that in 2008?
Your answer should be compact. 1.18. What is the ratio of the Balance of Payment (as % of service exports) in Nigeria in 2007 to that in 2008?
Your answer should be very brief. 1.08. What is the ratio of the Balance of Payment (as % of service exports) in Timor-Leste in 2007 to that in 2008?
Make the answer very short. 0.39. What is the ratio of the Balance of Payment (as % of service exports) of Greece in 2007 to that in 2009?
Give a very brief answer. 1.09. What is the ratio of the Balance of Payment (as % of service exports) in Marshall Islands in 2007 to that in 2009?
Give a very brief answer. 1.23. What is the ratio of the Balance of Payment (as % of service exports) in Nigeria in 2007 to that in 2009?
Offer a very short reply. 1.16. What is the ratio of the Balance of Payment (as % of service exports) in Timor-Leste in 2007 to that in 2009?
Provide a short and direct response. 0.4. What is the ratio of the Balance of Payment (as % of service exports) of Marshall Islands in 2007 to that in 2010?
Provide a short and direct response. 1.06. What is the ratio of the Balance of Payment (as % of service exports) in Nigeria in 2007 to that in 2010?
Keep it short and to the point. 0.9. What is the ratio of the Balance of Payment (as % of service exports) in Timor-Leste in 2007 to that in 2010?
Offer a very short reply. 0.34. What is the ratio of the Balance of Payment (as % of service exports) in Greece in 2007 to that in 2011?
Make the answer very short. 1.1. What is the ratio of the Balance of Payment (as % of service exports) in Marshall Islands in 2007 to that in 2011?
Provide a succinct answer. 1.09. What is the ratio of the Balance of Payment (as % of service exports) of Nigeria in 2007 to that in 2011?
Ensure brevity in your answer.  1.23. What is the ratio of the Balance of Payment (as % of service exports) of Timor-Leste in 2007 to that in 2011?
Offer a very short reply. 0.37. What is the ratio of the Balance of Payment (as % of service exports) in Greece in 2007 to that in 2012?
Provide a short and direct response. 1.11. What is the ratio of the Balance of Payment (as % of service exports) in Marshall Islands in 2007 to that in 2012?
Ensure brevity in your answer.  1.01. What is the ratio of the Balance of Payment (as % of service exports) in Timor-Leste in 2007 to that in 2012?
Keep it short and to the point. 0.35. What is the ratio of the Balance of Payment (as % of service exports) of Greece in 2008 to that in 2009?
Your answer should be very brief. 1.12. What is the ratio of the Balance of Payment (as % of service exports) in Marshall Islands in 2008 to that in 2009?
Offer a very short reply. 1.04. What is the ratio of the Balance of Payment (as % of service exports) of Nigeria in 2008 to that in 2009?
Keep it short and to the point. 1.08. What is the ratio of the Balance of Payment (as % of service exports) of Timor-Leste in 2008 to that in 2009?
Your answer should be very brief. 1.02. What is the ratio of the Balance of Payment (as % of service exports) of Greece in 2008 to that in 2010?
Provide a short and direct response. 1.03. What is the ratio of the Balance of Payment (as % of service exports) in Marshall Islands in 2008 to that in 2010?
Ensure brevity in your answer.  0.9. What is the ratio of the Balance of Payment (as % of service exports) in Nigeria in 2008 to that in 2010?
Your answer should be compact. 0.84. What is the ratio of the Balance of Payment (as % of service exports) of Timor-Leste in 2008 to that in 2010?
Provide a succinct answer. 0.86. What is the ratio of the Balance of Payment (as % of service exports) in Greece in 2008 to that in 2011?
Offer a terse response. 1.14. What is the ratio of the Balance of Payment (as % of service exports) in Marshall Islands in 2008 to that in 2011?
Keep it short and to the point. 0.92. What is the ratio of the Balance of Payment (as % of service exports) in Nigeria in 2008 to that in 2011?
Give a very brief answer. 1.14. What is the ratio of the Balance of Payment (as % of service exports) in Timor-Leste in 2008 to that in 2011?
Your response must be concise. 0.96. What is the ratio of the Balance of Payment (as % of service exports) in Greece in 2008 to that in 2012?
Offer a very short reply. 1.15. What is the ratio of the Balance of Payment (as % of service exports) of Marshall Islands in 2008 to that in 2012?
Provide a short and direct response. 0.86. What is the ratio of the Balance of Payment (as % of service exports) of Nigeria in 2008 to that in 2012?
Your answer should be compact. 0.92. What is the ratio of the Balance of Payment (as % of service exports) of Timor-Leste in 2008 to that in 2012?
Offer a very short reply. 0.9. What is the ratio of the Balance of Payment (as % of service exports) of Greece in 2009 to that in 2010?
Give a very brief answer. 0.92. What is the ratio of the Balance of Payment (as % of service exports) in Marshall Islands in 2009 to that in 2010?
Provide a short and direct response. 0.87. What is the ratio of the Balance of Payment (as % of service exports) in Nigeria in 2009 to that in 2010?
Your answer should be very brief. 0.77. What is the ratio of the Balance of Payment (as % of service exports) of Timor-Leste in 2009 to that in 2010?
Keep it short and to the point. 0.84. What is the ratio of the Balance of Payment (as % of service exports) of Greece in 2009 to that in 2011?
Keep it short and to the point. 1.02. What is the ratio of the Balance of Payment (as % of service exports) of Marshall Islands in 2009 to that in 2011?
Provide a succinct answer. 0.89. What is the ratio of the Balance of Payment (as % of service exports) in Nigeria in 2009 to that in 2011?
Your answer should be very brief. 1.06. What is the ratio of the Balance of Payment (as % of service exports) in Timor-Leste in 2009 to that in 2011?
Make the answer very short. 0.94. What is the ratio of the Balance of Payment (as % of service exports) in Greece in 2009 to that in 2012?
Provide a succinct answer. 1.03. What is the ratio of the Balance of Payment (as % of service exports) in Marshall Islands in 2009 to that in 2012?
Your answer should be very brief. 0.83. What is the ratio of the Balance of Payment (as % of service exports) in Nigeria in 2009 to that in 2012?
Offer a very short reply. 0.85. What is the ratio of the Balance of Payment (as % of service exports) of Timor-Leste in 2009 to that in 2012?
Your answer should be compact. 0.88. What is the ratio of the Balance of Payment (as % of service exports) in Greece in 2010 to that in 2011?
Your response must be concise. 1.11. What is the ratio of the Balance of Payment (as % of service exports) in Marshall Islands in 2010 to that in 2011?
Make the answer very short. 1.03. What is the ratio of the Balance of Payment (as % of service exports) of Nigeria in 2010 to that in 2011?
Your answer should be compact. 1.36. What is the ratio of the Balance of Payment (as % of service exports) of Timor-Leste in 2010 to that in 2011?
Make the answer very short. 1.12. What is the ratio of the Balance of Payment (as % of service exports) of Greece in 2010 to that in 2012?
Your answer should be compact. 1.12. What is the ratio of the Balance of Payment (as % of service exports) of Marshall Islands in 2010 to that in 2012?
Make the answer very short. 0.95. What is the ratio of the Balance of Payment (as % of service exports) of Nigeria in 2010 to that in 2012?
Keep it short and to the point. 1.1. What is the ratio of the Balance of Payment (as % of service exports) in Timor-Leste in 2010 to that in 2012?
Keep it short and to the point. 1.04. What is the ratio of the Balance of Payment (as % of service exports) of Greece in 2011 to that in 2012?
Your response must be concise. 1.01. What is the ratio of the Balance of Payment (as % of service exports) in Marshall Islands in 2011 to that in 2012?
Your answer should be very brief. 0.93. What is the ratio of the Balance of Payment (as % of service exports) in Nigeria in 2011 to that in 2012?
Your response must be concise. 0.81. What is the ratio of the Balance of Payment (as % of service exports) in Timor-Leste in 2011 to that in 2012?
Give a very brief answer. 0.94. What is the difference between the highest and the second highest Balance of Payment (as % of service exports) in Greece?
Provide a succinct answer. 1.62. What is the difference between the highest and the second highest Balance of Payment (as % of service exports) in Marshall Islands?
Offer a terse response. 0.52. What is the difference between the highest and the second highest Balance of Payment (as % of service exports) of Nigeria?
Provide a succinct answer. 15.53. What is the difference between the highest and the second highest Balance of Payment (as % of service exports) in Timor-Leste?
Give a very brief answer. 0.05. What is the difference between the highest and the lowest Balance of Payment (as % of service exports) in Greece?
Give a very brief answer. 7.47. What is the difference between the highest and the lowest Balance of Payment (as % of service exports) in Marshall Islands?
Ensure brevity in your answer.  5.67. What is the difference between the highest and the lowest Balance of Payment (as % of service exports) in Nigeria?
Keep it short and to the point. 32.6. What is the difference between the highest and the lowest Balance of Payment (as % of service exports) in Timor-Leste?
Make the answer very short. 0.77. 